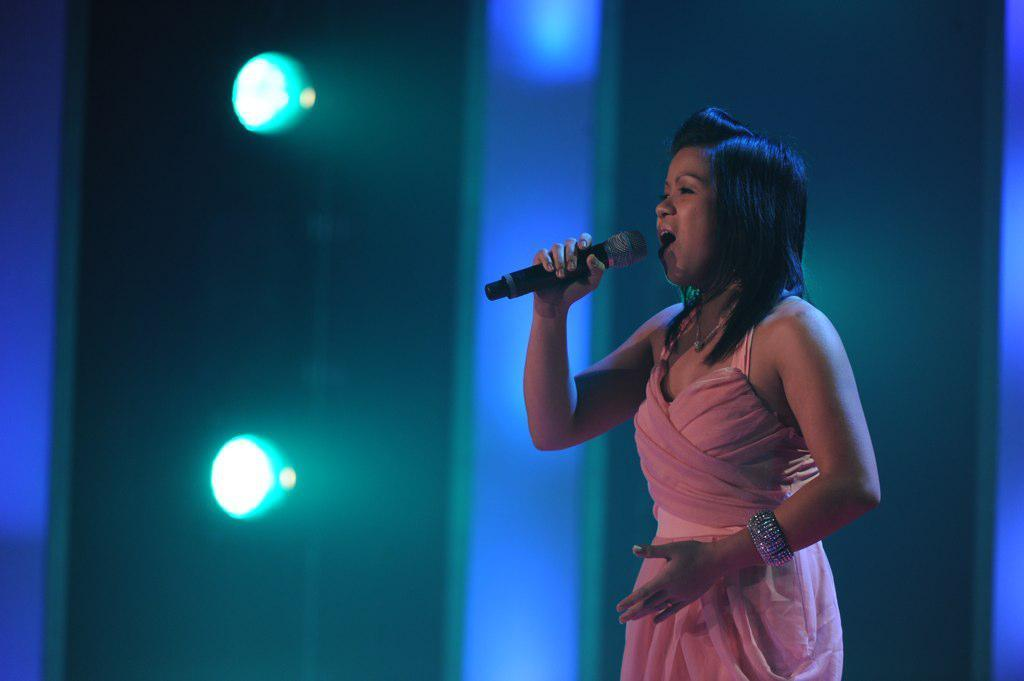Who is the main subject in the image? There is a woman in the image. What is the woman wearing? The woman is wearing a pink dress and a bangle. What is the woman holding in the image? The woman is holding a mic. What is the woman's posture in the image? The woman is standing. What can be seen in the background of the image? There are lights in the background of the image. How many walls are visible in the image? There are no walls visible in the image. 